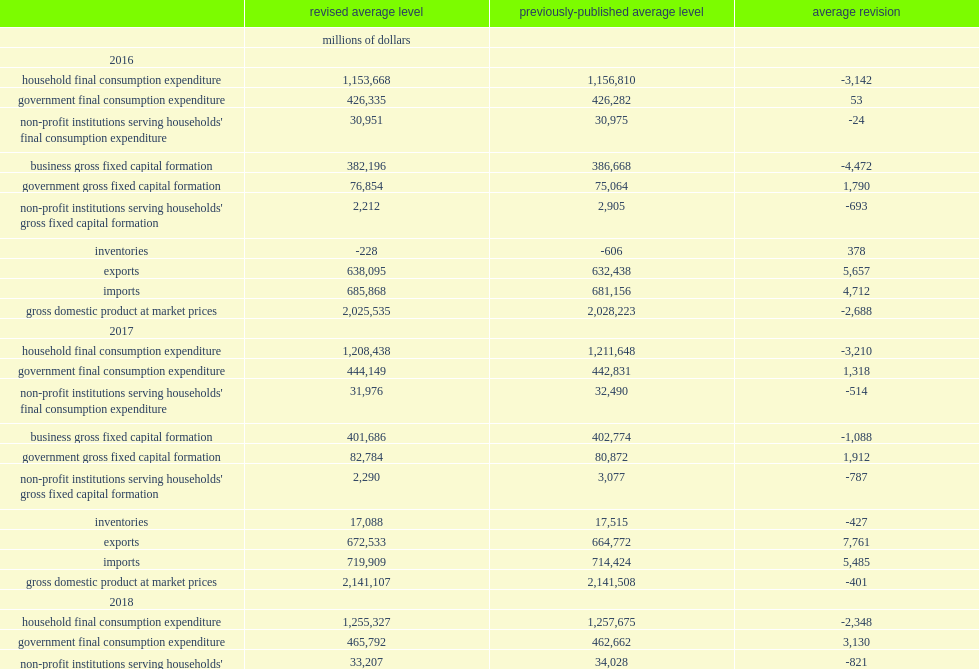How many dollars did governments' gross fixed capital formation contribute to revision in gdp in 2018? 4795.0. 